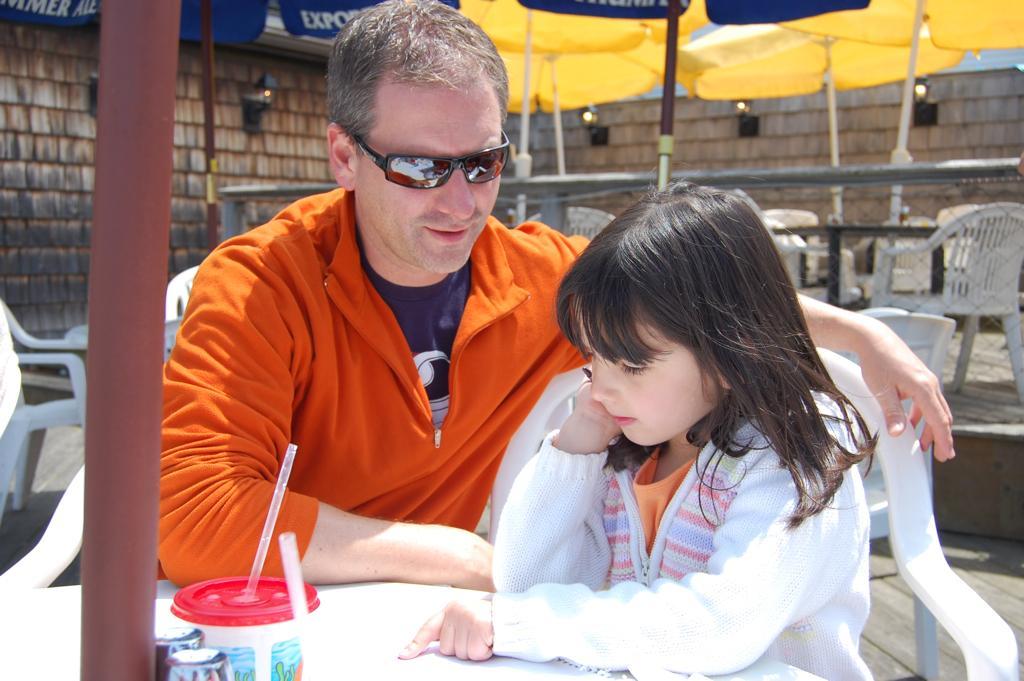In one or two sentences, can you explain what this image depicts? In this image there is a man and a girl sitting on chairs, in front of them there is a table, on that table there are bottles, in the background there are chairs, tables and umbrellas and a wall. 